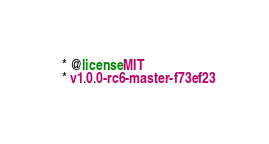Convert code to text. <code><loc_0><loc_0><loc_500><loc_500><_CSS_> * @license MIT
 * v1.0.0-rc6-master-f73ef23</code> 